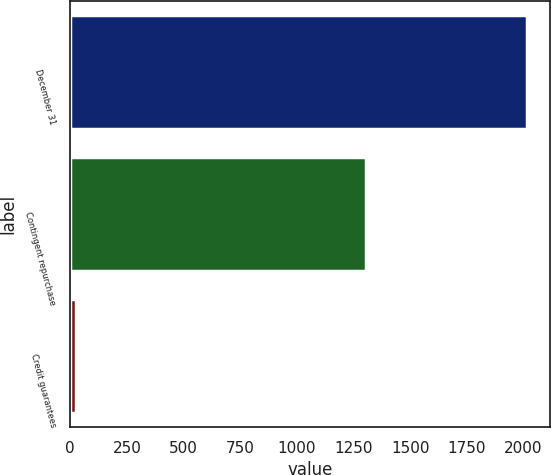Convert chart to OTSL. <chart><loc_0><loc_0><loc_500><loc_500><bar_chart><fcel>December 31<fcel>Contingent repurchase<fcel>Credit guarantees<nl><fcel>2016<fcel>1306<fcel>27<nl></chart> 